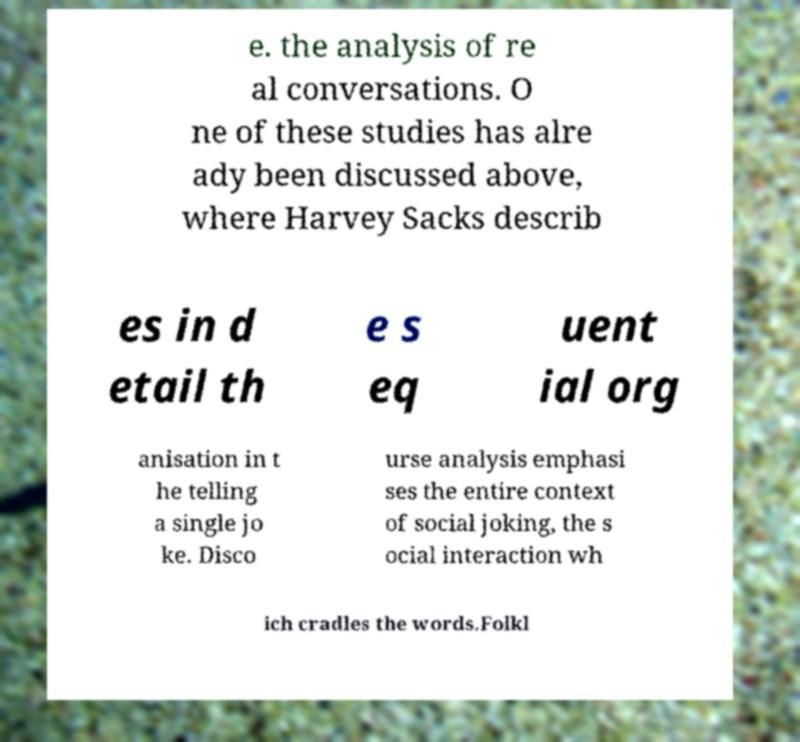Can you accurately transcribe the text from the provided image for me? e. the analysis of re al conversations. O ne of these studies has alre ady been discussed above, where Harvey Sacks describ es in d etail th e s eq uent ial org anisation in t he telling a single jo ke. Disco urse analysis emphasi ses the entire context of social joking, the s ocial interaction wh ich cradles the words.Folkl 